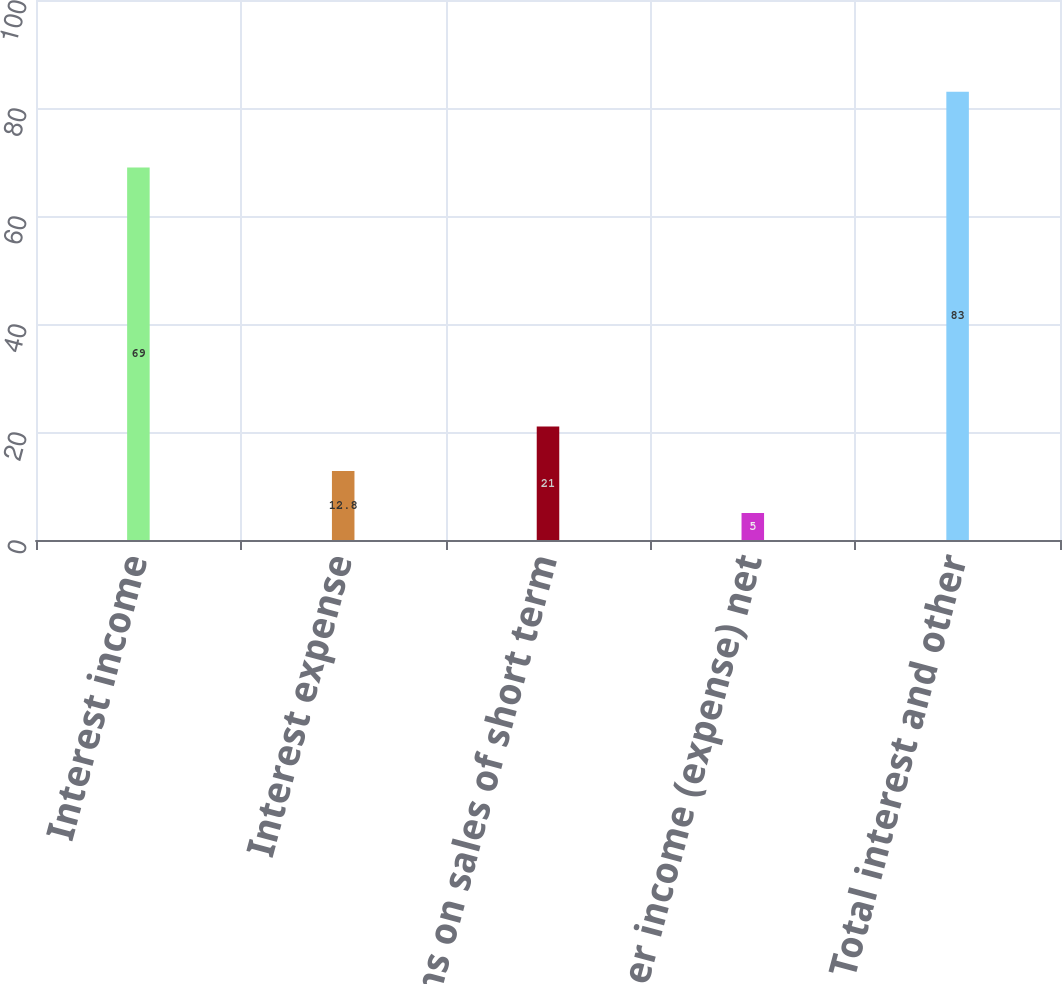<chart> <loc_0><loc_0><loc_500><loc_500><bar_chart><fcel>Interest income<fcel>Interest expense<fcel>Gains on sales of short term<fcel>Other income (expense) net<fcel>Total interest and other<nl><fcel>69<fcel>12.8<fcel>21<fcel>5<fcel>83<nl></chart> 